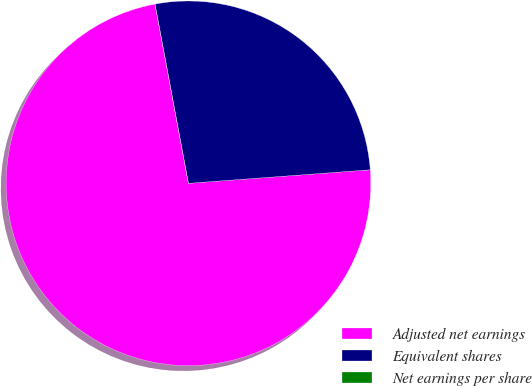Convert chart to OTSL. <chart><loc_0><loc_0><loc_500><loc_500><pie_chart><fcel>Adjusted net earnings<fcel>Equivalent shares<fcel>Net earnings per share<nl><fcel>73.25%<fcel>26.75%<fcel>0.0%<nl></chart> 